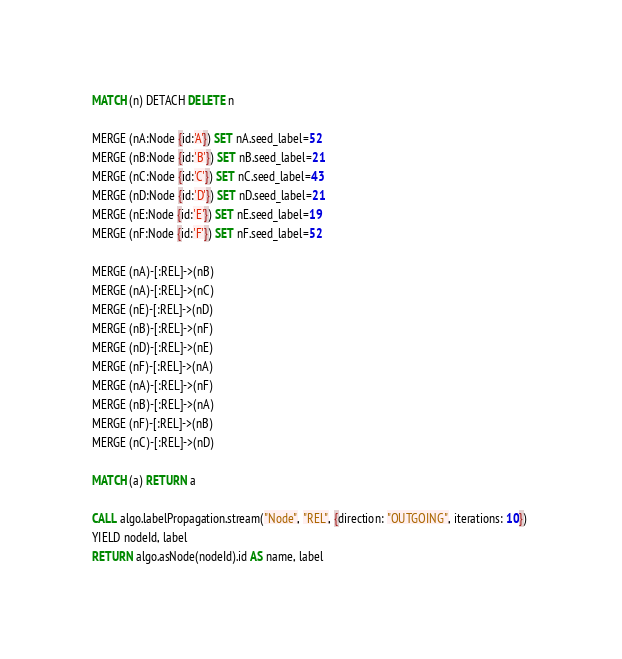Convert code to text. <code><loc_0><loc_0><loc_500><loc_500><_SQL_>MATCH (n) DETACH DELETE n

MERGE (nA:Node {id:'A'}) SET nA.seed_label=52
MERGE (nB:Node {id:'B'}) SET nB.seed_label=21
MERGE (nC:Node {id:'C'}) SET nC.seed_label=43
MERGE (nD:Node {id:'D'}) SET nD.seed_label=21
MERGE (nE:Node {id:'E'}) SET nE.seed_label=19
MERGE (nF:Node {id:'F'}) SET nF.seed_label=52

MERGE (nA)-[:REL]->(nB)
MERGE (nA)-[:REL]->(nC)
MERGE (nE)-[:REL]->(nD)
MERGE (nB)-[:REL]->(nF)
MERGE (nD)-[:REL]->(nE)
MERGE (nF)-[:REL]->(nA)
MERGE (nA)-[:REL]->(nF)
MERGE (nB)-[:REL]->(nA)
MERGE (nF)-[:REL]->(nB)
MERGE (nC)-[:REL]->(nD)

MATCH (a) RETURN a

CALL algo.labelPropagation.stream("Node", "REL", {direction: "OUTGOING", iterations: 10}) 
YIELD nodeId, label 
RETURN algo.asNode(nodeId).id AS name, label
</code> 